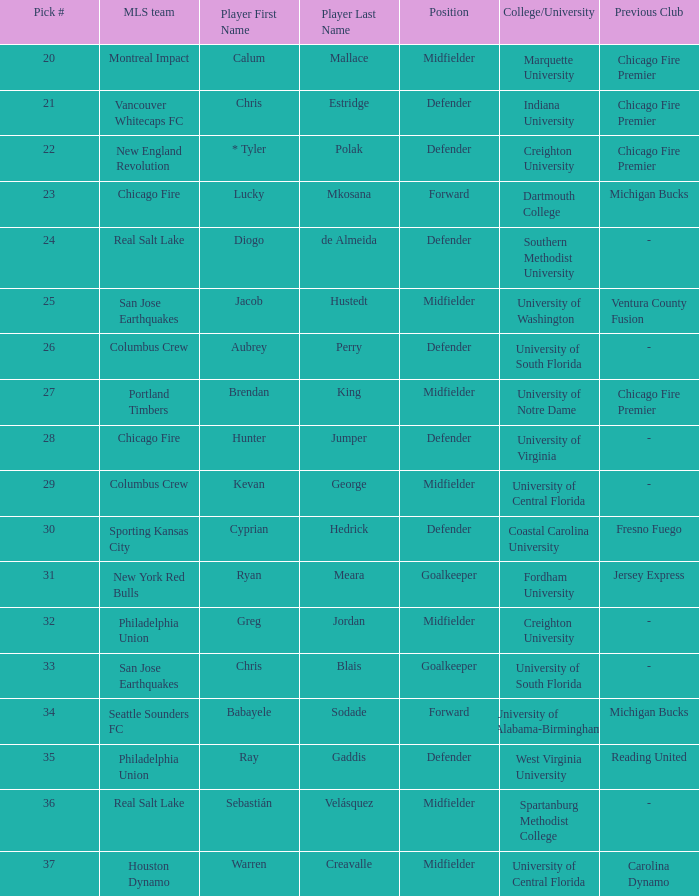What selection number did real salt lake receive? 24.0. 